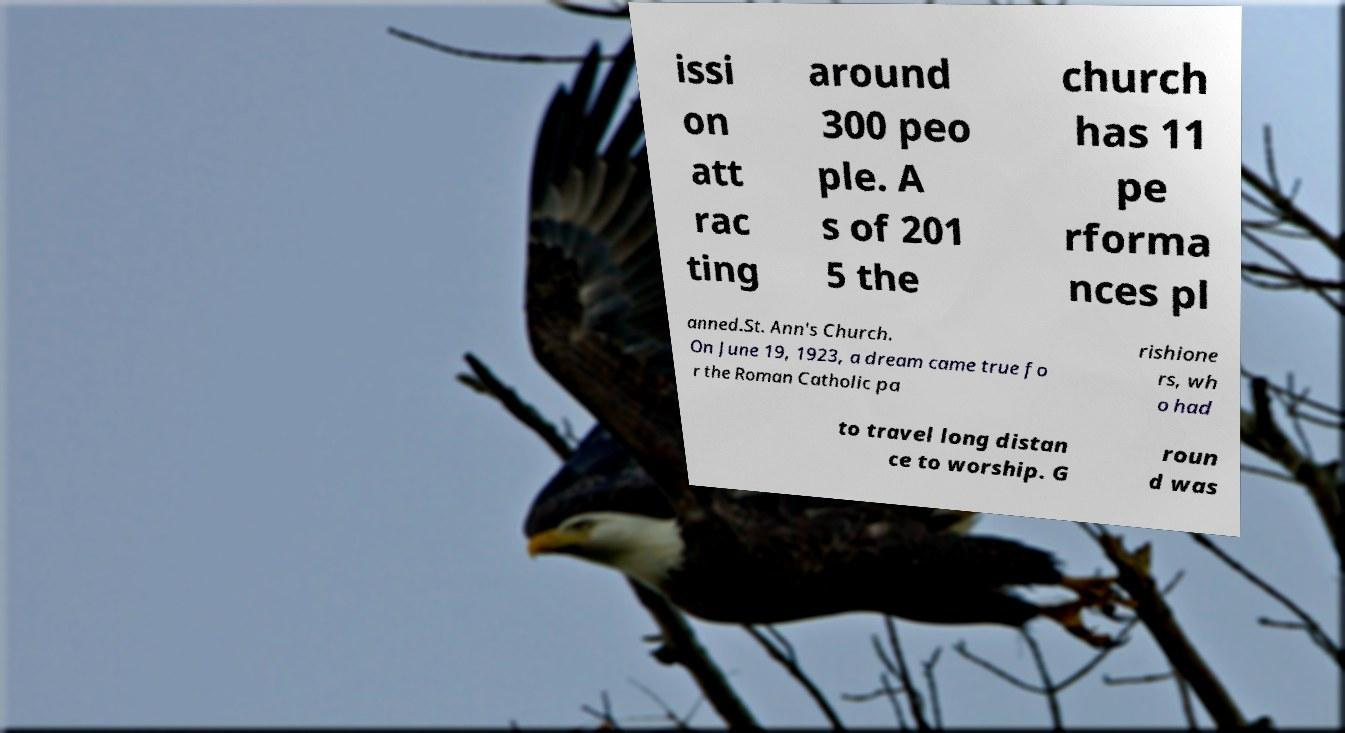Please identify and transcribe the text found in this image. issi on att rac ting around 300 peo ple. A s of 201 5 the church has 11 pe rforma nces pl anned.St. Ann's Church. On June 19, 1923, a dream came true fo r the Roman Catholic pa rishione rs, wh o had to travel long distan ce to worship. G roun d was 